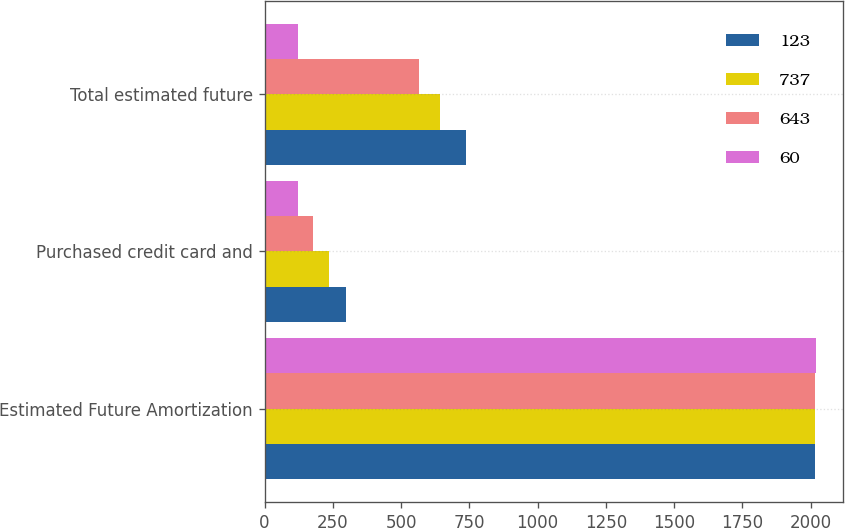Convert chart to OTSL. <chart><loc_0><loc_0><loc_500><loc_500><stacked_bar_chart><ecel><fcel>Estimated Future Amortization<fcel>Purchased credit card and<fcel>Total estimated future<nl><fcel>123<fcel>2016<fcel>298<fcel>737<nl><fcel>737<fcel>2017<fcel>237<fcel>643<nl><fcel>643<fcel>2018<fcel>179<fcel>565<nl><fcel>60<fcel>2019<fcel>121<fcel>123<nl></chart> 